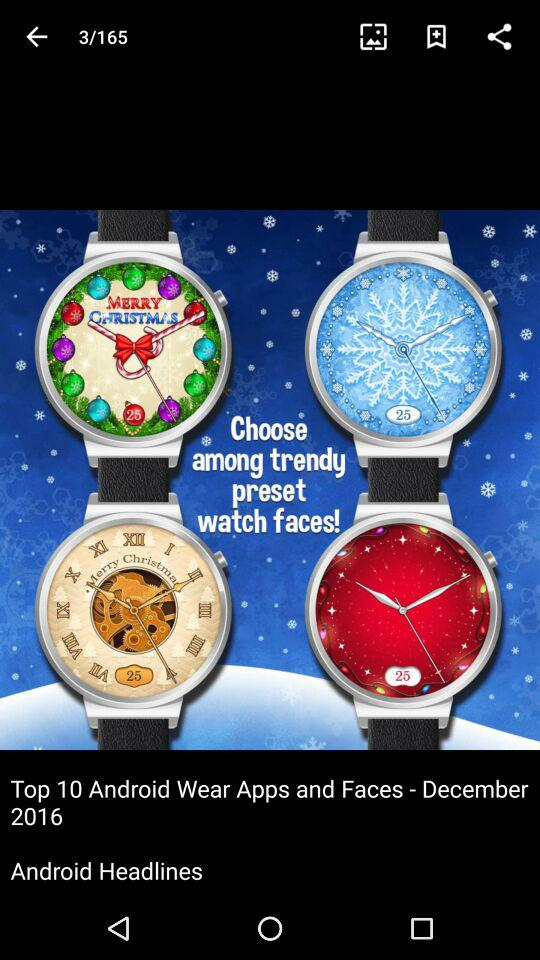On which date are the details of the article given?
When the provided information is insufficient, respond with <no answer>. <no answer> 